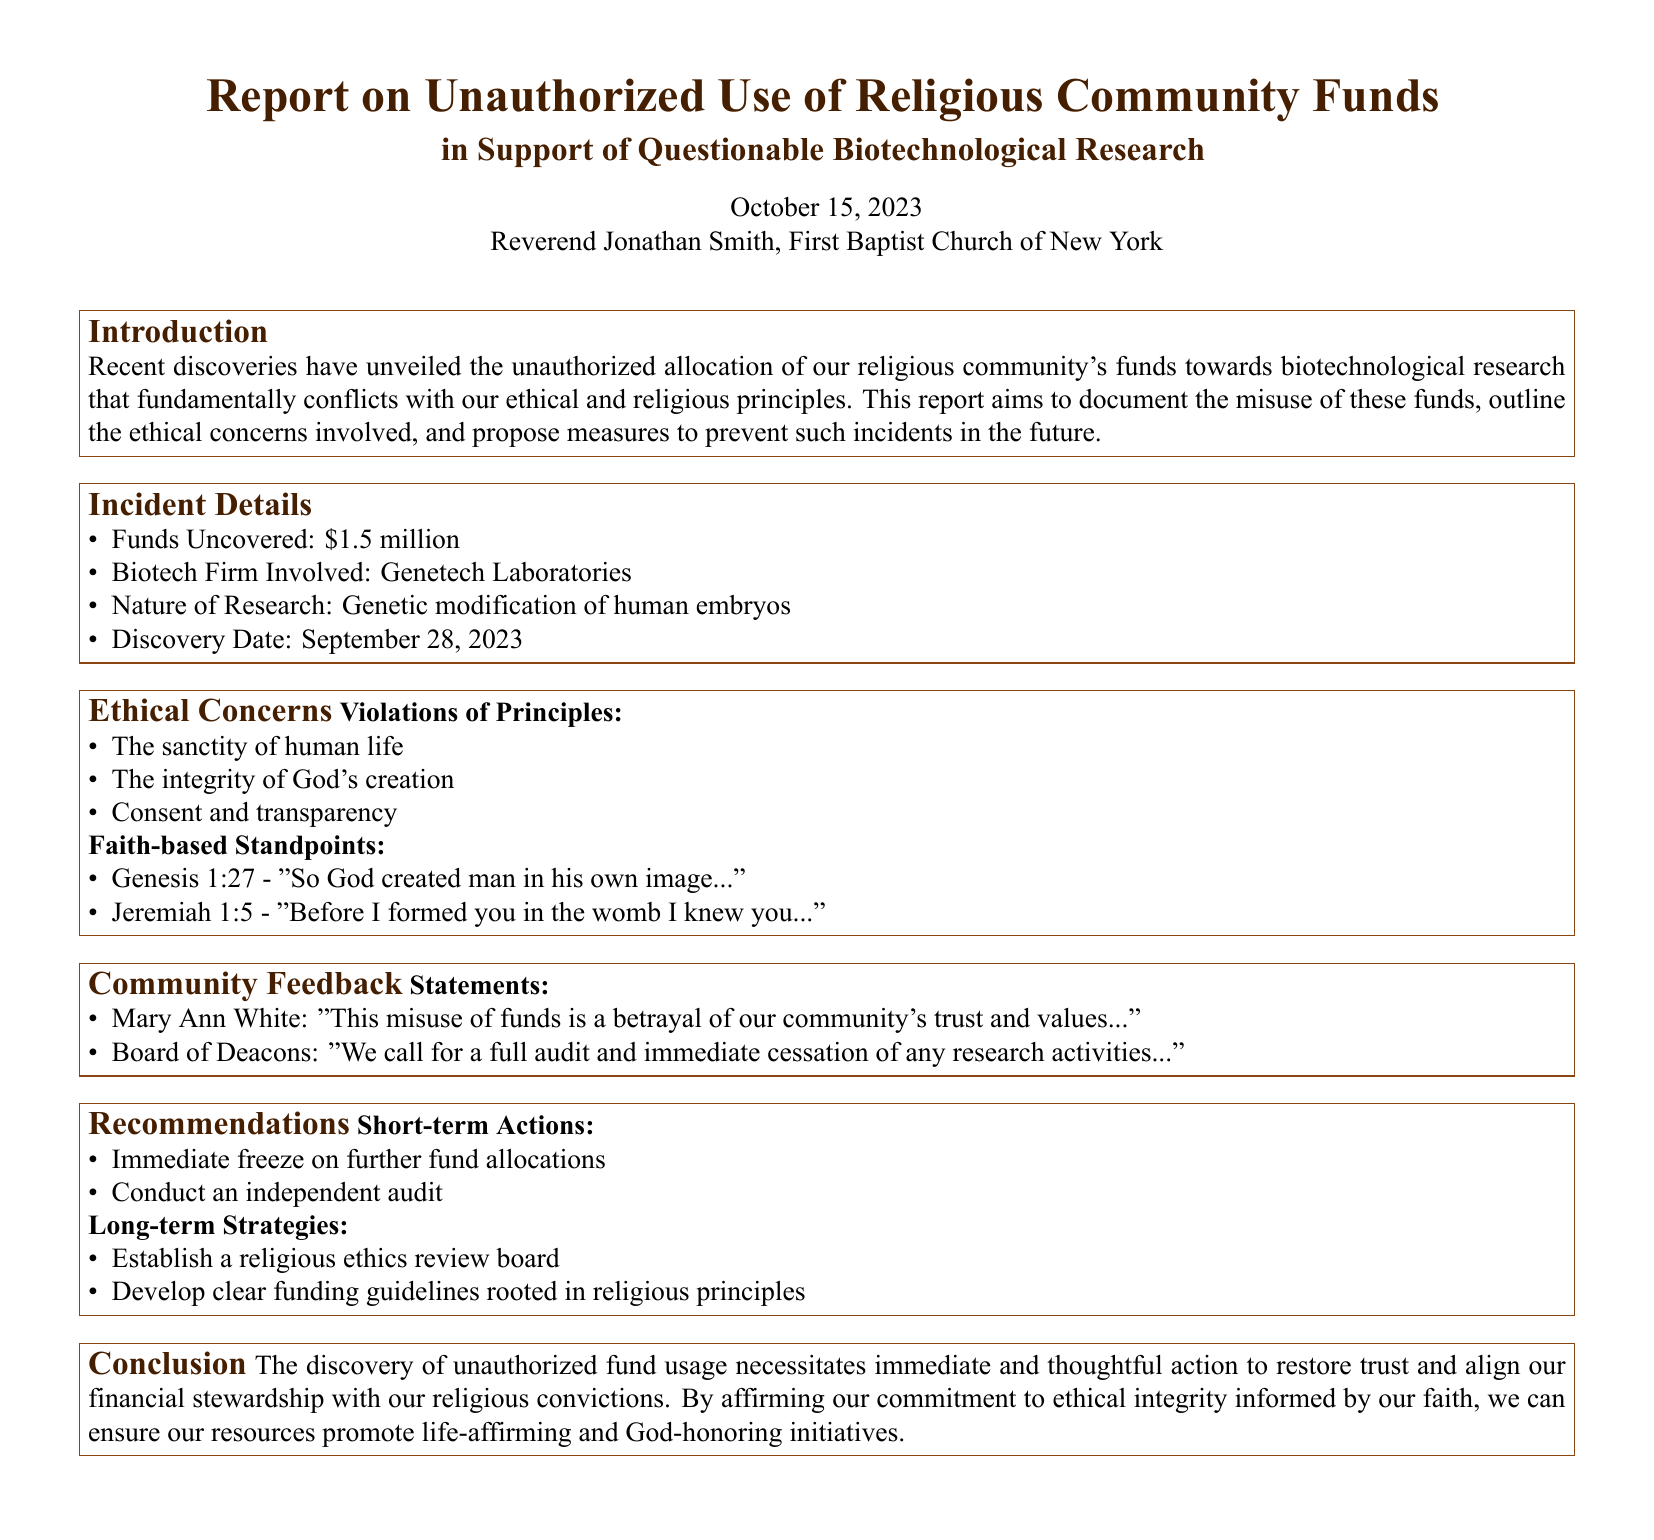What is the amount of funds uncovered? The report specifies that $1.5 million in funds were uncovered related to the incident.
Answer: $1.5 million Who is the biotech firm involved in the incident? The document identifies Genetech Laboratories as the firm that misused the funds.
Answer: Genetech Laboratories What is the nature of the research funded? According to the report, the research involves genetic modification of human embryos.
Answer: Genetic modification of human embryos On what date was the discovery made? The report states that the discovery was made on September 28, 2023.
Answer: September 28, 2023 What is one of the ethical principles violated according to the report? The document lists various ethical principles; one of them is the sanctity of human life.
Answer: Sanctity of human life What does Genesis 1:27 emphasize regarding human creation? The verse cited emphasizes that God created man in His own image, relating to the ethical debate.
Answer: "So God created man in his own image..." What recommendation is made for short-term actions? The report recommends an immediate freeze on further fund allocations as a key short-term action.
Answer: Immediate freeze on further fund allocations What long-term strategy does the report suggest establishing? The document suggests establishing a religious ethics review board as part of long-term strategies to prevent future issues.
Answer: Religious ethics review board What community feedback is mentioned from the Board of Deacons? The Board of Deacons called for a full audit and immediate cessation of research activities.
Answer: Full audit and immediate cessation of any research activities 